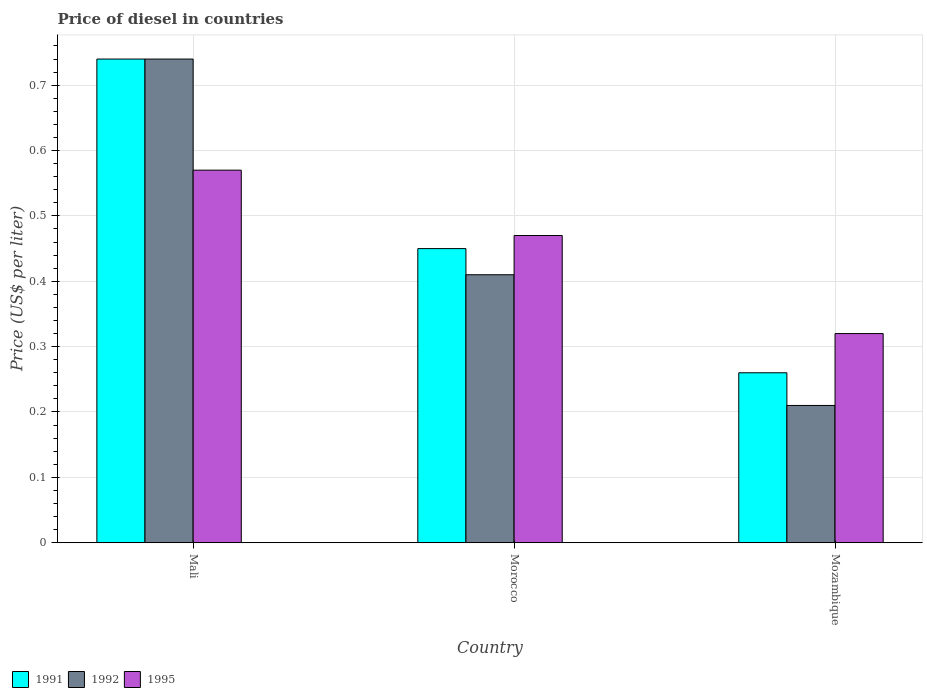Are the number of bars on each tick of the X-axis equal?
Provide a short and direct response. Yes. What is the label of the 2nd group of bars from the left?
Offer a terse response. Morocco. What is the price of diesel in 1991 in Morocco?
Provide a succinct answer. 0.45. Across all countries, what is the maximum price of diesel in 1995?
Keep it short and to the point. 0.57. Across all countries, what is the minimum price of diesel in 1992?
Make the answer very short. 0.21. In which country was the price of diesel in 1995 maximum?
Your response must be concise. Mali. In which country was the price of diesel in 1992 minimum?
Your answer should be compact. Mozambique. What is the total price of diesel in 1991 in the graph?
Your answer should be very brief. 1.45. What is the difference between the price of diesel in 1991 in Mali and that in Morocco?
Offer a very short reply. 0.29. What is the difference between the price of diesel in 1992 in Mali and the price of diesel in 1991 in Mozambique?
Your response must be concise. 0.48. What is the average price of diesel in 1991 per country?
Make the answer very short. 0.48. What is the difference between the price of diesel of/in 1995 and price of diesel of/in 1991 in Mozambique?
Your answer should be compact. 0.06. What is the ratio of the price of diesel in 1991 in Mali to that in Morocco?
Ensure brevity in your answer.  1.64. Is the difference between the price of diesel in 1995 in Mali and Morocco greater than the difference between the price of diesel in 1991 in Mali and Morocco?
Ensure brevity in your answer.  No. What is the difference between the highest and the second highest price of diesel in 1995?
Ensure brevity in your answer.  0.1. What is the difference between the highest and the lowest price of diesel in 1995?
Your answer should be compact. 0.25. Is the sum of the price of diesel in 1991 in Mali and Morocco greater than the maximum price of diesel in 1995 across all countries?
Your answer should be very brief. Yes. What does the 1st bar from the right in Morocco represents?
Keep it short and to the point. 1995. Are all the bars in the graph horizontal?
Give a very brief answer. No. How many countries are there in the graph?
Your response must be concise. 3. Does the graph contain any zero values?
Ensure brevity in your answer.  No. How many legend labels are there?
Your answer should be compact. 3. What is the title of the graph?
Your response must be concise. Price of diesel in countries. What is the label or title of the Y-axis?
Keep it short and to the point. Price (US$ per liter). What is the Price (US$ per liter) in 1991 in Mali?
Keep it short and to the point. 0.74. What is the Price (US$ per liter) in 1992 in Mali?
Keep it short and to the point. 0.74. What is the Price (US$ per liter) of 1995 in Mali?
Provide a succinct answer. 0.57. What is the Price (US$ per liter) in 1991 in Morocco?
Your answer should be compact. 0.45. What is the Price (US$ per liter) of 1992 in Morocco?
Keep it short and to the point. 0.41. What is the Price (US$ per liter) in 1995 in Morocco?
Ensure brevity in your answer.  0.47. What is the Price (US$ per liter) in 1991 in Mozambique?
Provide a succinct answer. 0.26. What is the Price (US$ per liter) in 1992 in Mozambique?
Provide a succinct answer. 0.21. What is the Price (US$ per liter) of 1995 in Mozambique?
Provide a succinct answer. 0.32. Across all countries, what is the maximum Price (US$ per liter) in 1991?
Offer a very short reply. 0.74. Across all countries, what is the maximum Price (US$ per liter) in 1992?
Ensure brevity in your answer.  0.74. Across all countries, what is the maximum Price (US$ per liter) in 1995?
Offer a very short reply. 0.57. Across all countries, what is the minimum Price (US$ per liter) in 1991?
Your response must be concise. 0.26. Across all countries, what is the minimum Price (US$ per liter) of 1992?
Your response must be concise. 0.21. Across all countries, what is the minimum Price (US$ per liter) of 1995?
Provide a short and direct response. 0.32. What is the total Price (US$ per liter) in 1991 in the graph?
Your answer should be very brief. 1.45. What is the total Price (US$ per liter) in 1992 in the graph?
Provide a succinct answer. 1.36. What is the total Price (US$ per liter) of 1995 in the graph?
Provide a succinct answer. 1.36. What is the difference between the Price (US$ per liter) of 1991 in Mali and that in Morocco?
Your response must be concise. 0.29. What is the difference between the Price (US$ per liter) in 1992 in Mali and that in Morocco?
Your answer should be compact. 0.33. What is the difference between the Price (US$ per liter) of 1995 in Mali and that in Morocco?
Your response must be concise. 0.1. What is the difference between the Price (US$ per liter) in 1991 in Mali and that in Mozambique?
Ensure brevity in your answer.  0.48. What is the difference between the Price (US$ per liter) in 1992 in Mali and that in Mozambique?
Provide a short and direct response. 0.53. What is the difference between the Price (US$ per liter) of 1991 in Morocco and that in Mozambique?
Provide a short and direct response. 0.19. What is the difference between the Price (US$ per liter) of 1992 in Morocco and that in Mozambique?
Give a very brief answer. 0.2. What is the difference between the Price (US$ per liter) of 1995 in Morocco and that in Mozambique?
Provide a succinct answer. 0.15. What is the difference between the Price (US$ per liter) in 1991 in Mali and the Price (US$ per liter) in 1992 in Morocco?
Ensure brevity in your answer.  0.33. What is the difference between the Price (US$ per liter) of 1991 in Mali and the Price (US$ per liter) of 1995 in Morocco?
Offer a terse response. 0.27. What is the difference between the Price (US$ per liter) of 1992 in Mali and the Price (US$ per liter) of 1995 in Morocco?
Ensure brevity in your answer.  0.27. What is the difference between the Price (US$ per liter) in 1991 in Mali and the Price (US$ per liter) in 1992 in Mozambique?
Provide a short and direct response. 0.53. What is the difference between the Price (US$ per liter) in 1991 in Mali and the Price (US$ per liter) in 1995 in Mozambique?
Provide a succinct answer. 0.42. What is the difference between the Price (US$ per liter) of 1992 in Mali and the Price (US$ per liter) of 1995 in Mozambique?
Provide a short and direct response. 0.42. What is the difference between the Price (US$ per liter) in 1991 in Morocco and the Price (US$ per liter) in 1992 in Mozambique?
Keep it short and to the point. 0.24. What is the difference between the Price (US$ per liter) of 1991 in Morocco and the Price (US$ per liter) of 1995 in Mozambique?
Keep it short and to the point. 0.13. What is the difference between the Price (US$ per liter) in 1992 in Morocco and the Price (US$ per liter) in 1995 in Mozambique?
Offer a very short reply. 0.09. What is the average Price (US$ per liter) in 1991 per country?
Provide a short and direct response. 0.48. What is the average Price (US$ per liter) of 1992 per country?
Provide a short and direct response. 0.45. What is the average Price (US$ per liter) of 1995 per country?
Keep it short and to the point. 0.45. What is the difference between the Price (US$ per liter) in 1991 and Price (US$ per liter) in 1995 in Mali?
Give a very brief answer. 0.17. What is the difference between the Price (US$ per liter) of 1992 and Price (US$ per liter) of 1995 in Mali?
Your answer should be compact. 0.17. What is the difference between the Price (US$ per liter) in 1991 and Price (US$ per liter) in 1992 in Morocco?
Provide a short and direct response. 0.04. What is the difference between the Price (US$ per liter) of 1991 and Price (US$ per liter) of 1995 in Morocco?
Offer a very short reply. -0.02. What is the difference between the Price (US$ per liter) in 1992 and Price (US$ per liter) in 1995 in Morocco?
Offer a terse response. -0.06. What is the difference between the Price (US$ per liter) of 1991 and Price (US$ per liter) of 1995 in Mozambique?
Make the answer very short. -0.06. What is the difference between the Price (US$ per liter) of 1992 and Price (US$ per liter) of 1995 in Mozambique?
Keep it short and to the point. -0.11. What is the ratio of the Price (US$ per liter) in 1991 in Mali to that in Morocco?
Ensure brevity in your answer.  1.64. What is the ratio of the Price (US$ per liter) in 1992 in Mali to that in Morocco?
Your answer should be very brief. 1.8. What is the ratio of the Price (US$ per liter) in 1995 in Mali to that in Morocco?
Your answer should be very brief. 1.21. What is the ratio of the Price (US$ per liter) of 1991 in Mali to that in Mozambique?
Your answer should be very brief. 2.85. What is the ratio of the Price (US$ per liter) of 1992 in Mali to that in Mozambique?
Make the answer very short. 3.52. What is the ratio of the Price (US$ per liter) in 1995 in Mali to that in Mozambique?
Your response must be concise. 1.78. What is the ratio of the Price (US$ per liter) in 1991 in Morocco to that in Mozambique?
Keep it short and to the point. 1.73. What is the ratio of the Price (US$ per liter) of 1992 in Morocco to that in Mozambique?
Ensure brevity in your answer.  1.95. What is the ratio of the Price (US$ per liter) of 1995 in Morocco to that in Mozambique?
Make the answer very short. 1.47. What is the difference between the highest and the second highest Price (US$ per liter) in 1991?
Keep it short and to the point. 0.29. What is the difference between the highest and the second highest Price (US$ per liter) of 1992?
Your response must be concise. 0.33. What is the difference between the highest and the second highest Price (US$ per liter) in 1995?
Your answer should be compact. 0.1. What is the difference between the highest and the lowest Price (US$ per liter) in 1991?
Your answer should be compact. 0.48. What is the difference between the highest and the lowest Price (US$ per liter) in 1992?
Provide a short and direct response. 0.53. 